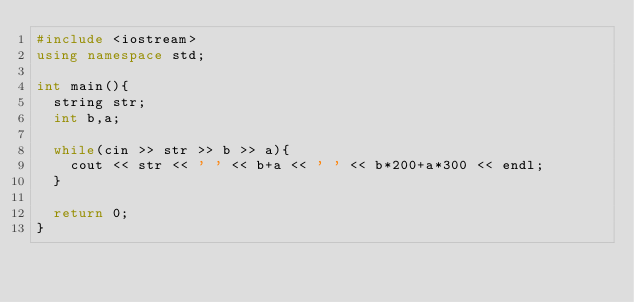<code> <loc_0><loc_0><loc_500><loc_500><_C++_>#include <iostream>
using namespace std;

int main(){
  string str;
  int b,a;

  while(cin >> str >> b >> a){
    cout << str << ' ' << b+a << ' ' << b*200+a*300 << endl;
  }

  return 0;
}</code> 